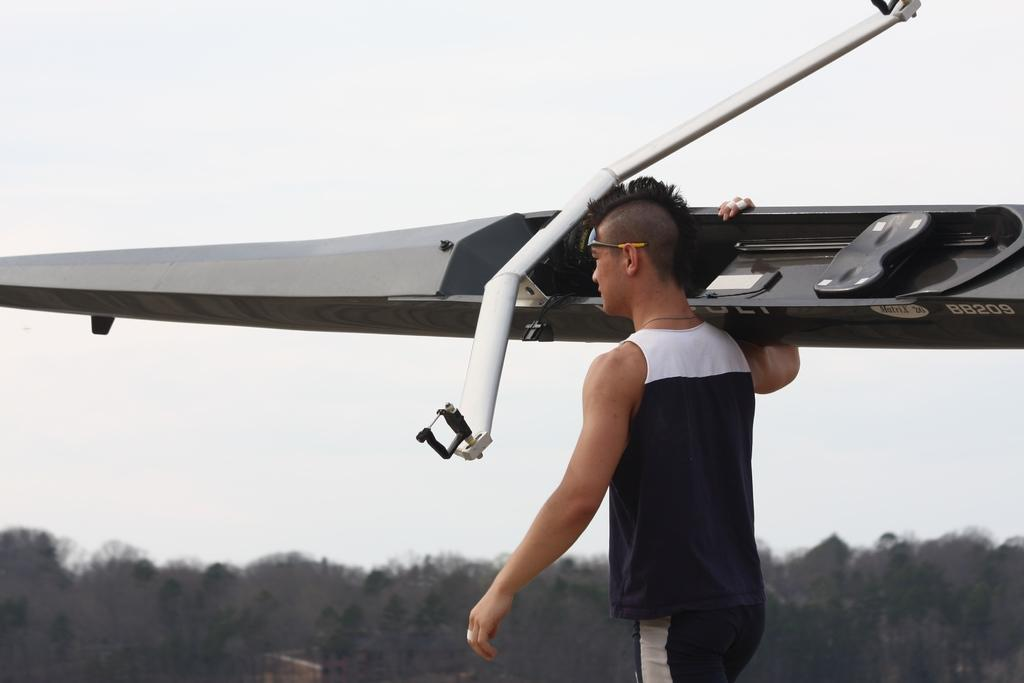<image>
Share a concise interpretation of the image provided. The Matrix 26 glider's identification number is BB209. 